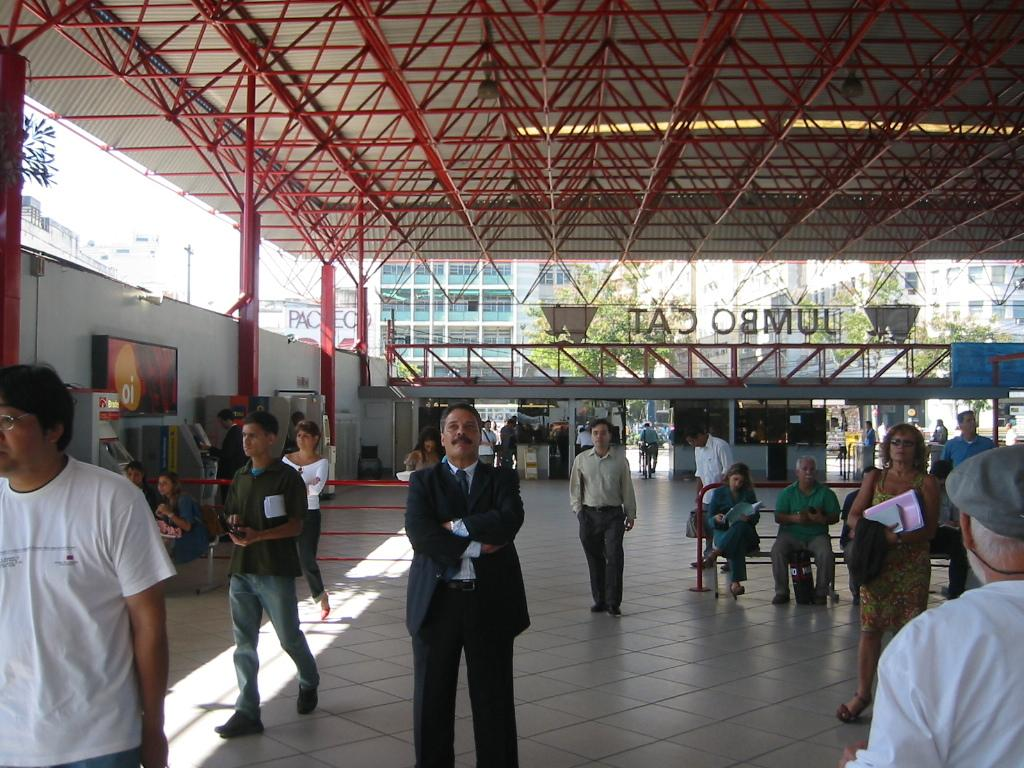What can be seen in the front of the image? In the front of the image, there are people, benches, machines, railing, boards, and objects under a shed. What is the purpose of the benches in the image? The benches in the image are likely for sitting or resting. What are the machines used for in the image? The specific purpose of the machines cannot be determined from the image, but they may be used for work or production. What is the railing used for? The railing in the image is likely for safety or to prevent people from falling. What can be seen on the boards in the image? The boards in the image have objects on them, but their specific purpose cannot be determined. What is under the shed in the image? There are objects under the shed in the image, but their specific purpose cannot be determined. What can be seen in the background of the image? In the background of the image, there are buildings, trees, and a pole. How many basins are visible in the image? There are no basins present in the image. What type of tray is being used by the people in the image? There are no trays visible in the image. 